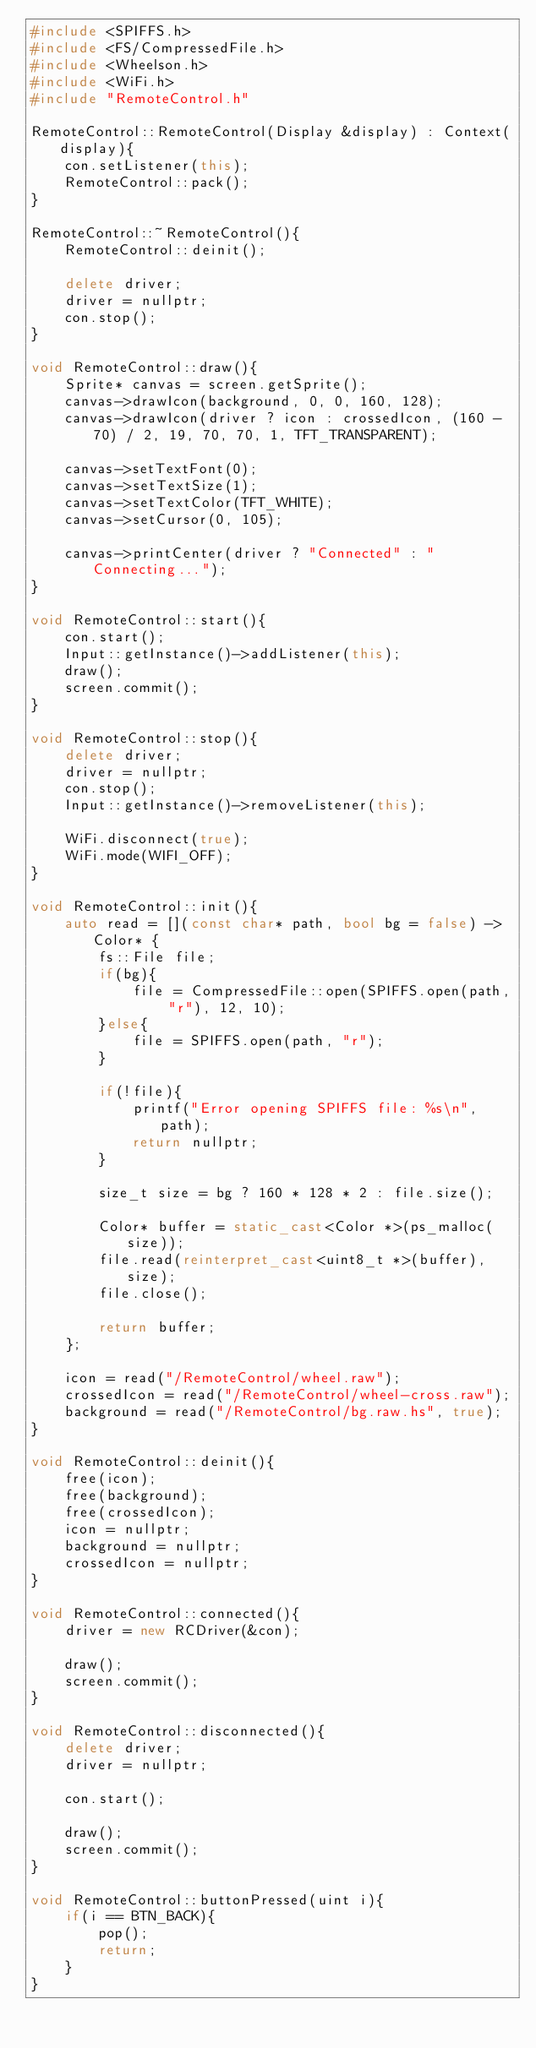<code> <loc_0><loc_0><loc_500><loc_500><_C++_>#include <SPIFFS.h>
#include <FS/CompressedFile.h>
#include <Wheelson.h>
#include <WiFi.h>
#include "RemoteControl.h"

RemoteControl::RemoteControl(Display &display) : Context(display){
	con.setListener(this);
	RemoteControl::pack();
}

RemoteControl::~RemoteControl(){
	RemoteControl::deinit();

	delete driver;
	driver = nullptr;
	con.stop();
}

void RemoteControl::draw(){
	Sprite* canvas = screen.getSprite();
	canvas->drawIcon(background, 0, 0, 160, 128);
	canvas->drawIcon(driver ? icon : crossedIcon, (160 - 70) / 2, 19, 70, 70, 1, TFT_TRANSPARENT);

	canvas->setTextFont(0);
	canvas->setTextSize(1);
	canvas->setTextColor(TFT_WHITE);
	canvas->setCursor(0, 105);

	canvas->printCenter(driver ? "Connected" : "Connecting...");
}

void RemoteControl::start(){
	con.start();
	Input::getInstance()->addListener(this);
	draw();
	screen.commit();
}

void RemoteControl::stop(){
	delete driver;
	driver = nullptr;
	con.stop();
	Input::getInstance()->removeListener(this);

	WiFi.disconnect(true);
	WiFi.mode(WIFI_OFF);
}

void RemoteControl::init(){
	auto read = [](const char* path, bool bg = false) -> Color* {
		fs::File file;
		if(bg){
			file = CompressedFile::open(SPIFFS.open(path, "r"), 12, 10);
		}else{
			file = SPIFFS.open(path, "r");
		}

		if(!file){
			printf("Error opening SPIFFS file: %s\n", path);
			return nullptr;
		}

		size_t size = bg ? 160 * 128 * 2 : file.size();

		Color* buffer = static_cast<Color *>(ps_malloc(size));
		file.read(reinterpret_cast<uint8_t *>(buffer), size);
		file.close();

		return buffer;
	};

	icon = read("/RemoteControl/wheel.raw");
	crossedIcon = read("/RemoteControl/wheel-cross.raw");
	background = read("/RemoteControl/bg.raw.hs", true);
}

void RemoteControl::deinit(){
	free(icon);
	free(background);
	free(crossedIcon);
	icon = nullptr;
	background = nullptr;
	crossedIcon = nullptr;
}

void RemoteControl::connected(){
	driver = new RCDriver(&con);

	draw();
	screen.commit();
}

void RemoteControl::disconnected(){
	delete driver;
	driver = nullptr;

	con.start();

	draw();
	screen.commit();
}

void RemoteControl::buttonPressed(uint i){
	if(i == BTN_BACK){
		pop();
		return;
	}
}
</code> 